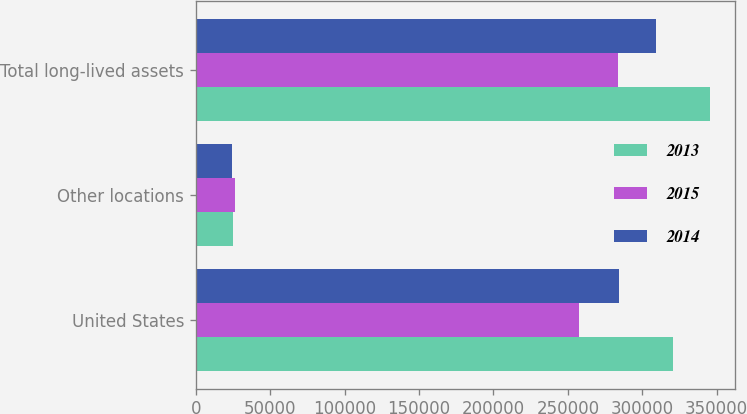Convert chart. <chart><loc_0><loc_0><loc_500><loc_500><stacked_bar_chart><ecel><fcel>United States<fcel>Other locations<fcel>Total long-lived assets<nl><fcel>2013<fcel>320445<fcel>24878<fcel>345323<nl><fcel>2015<fcel>257587<fcel>26254<fcel>283841<nl><fcel>2014<fcel>284693<fcel>24567<fcel>309260<nl></chart> 